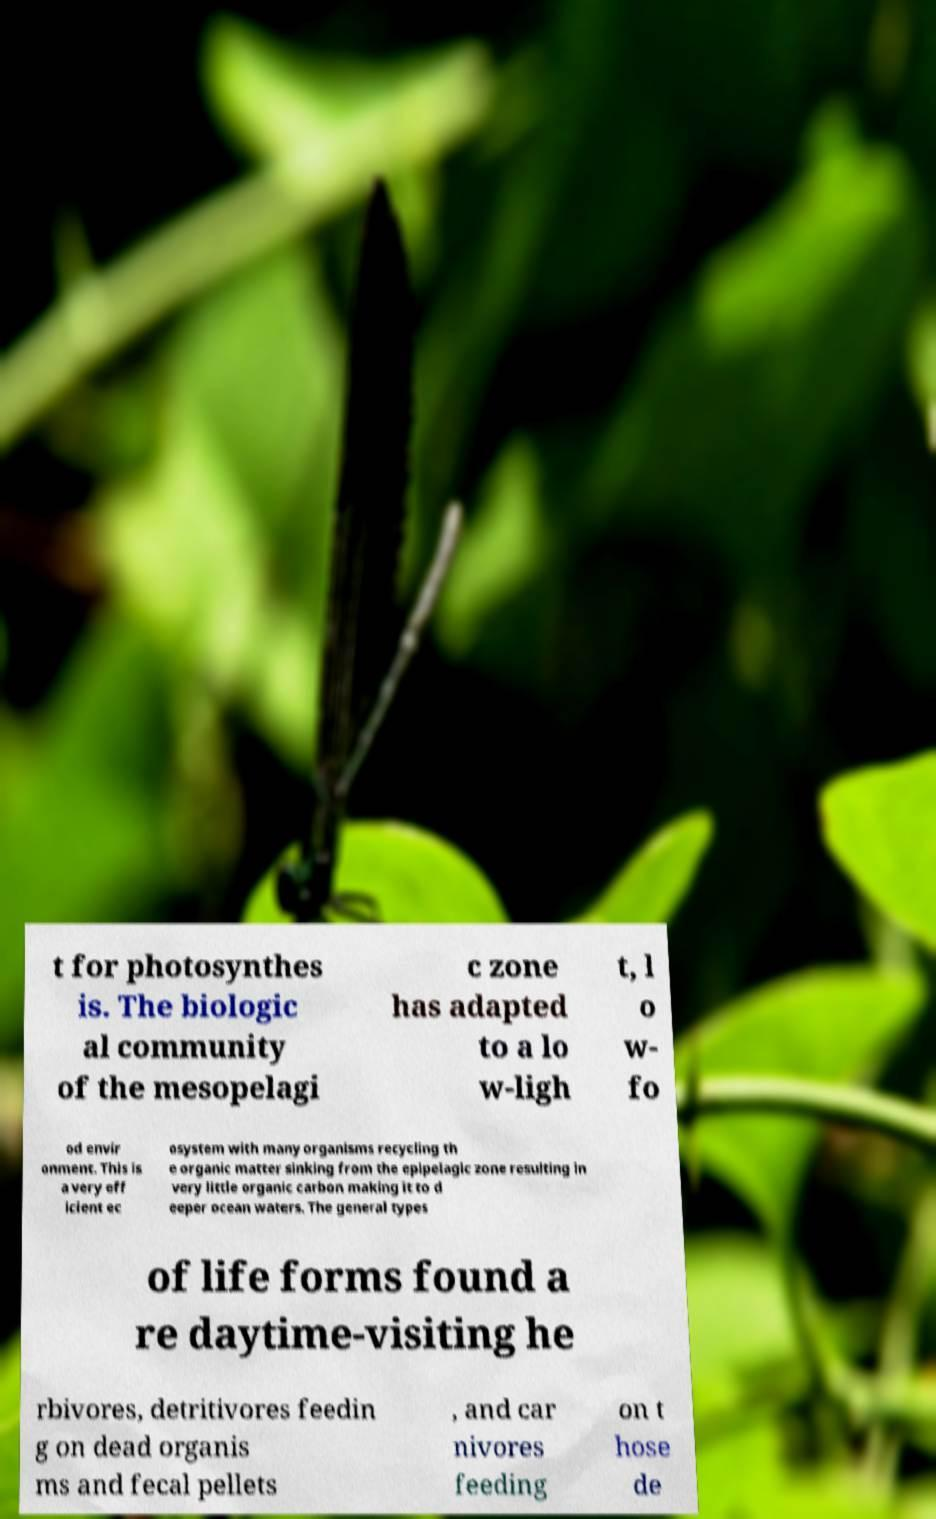Can you read and provide the text displayed in the image?This photo seems to have some interesting text. Can you extract and type it out for me? t for photosynthes is. The biologic al community of the mesopelagi c zone has adapted to a lo w-ligh t, l o w- fo od envir onment. This is a very eff icient ec osystem with many organisms recycling th e organic matter sinking from the epipelagic zone resulting in very little organic carbon making it to d eeper ocean waters. The general types of life forms found a re daytime-visiting he rbivores, detritivores feedin g on dead organis ms and fecal pellets , and car nivores feeding on t hose de 